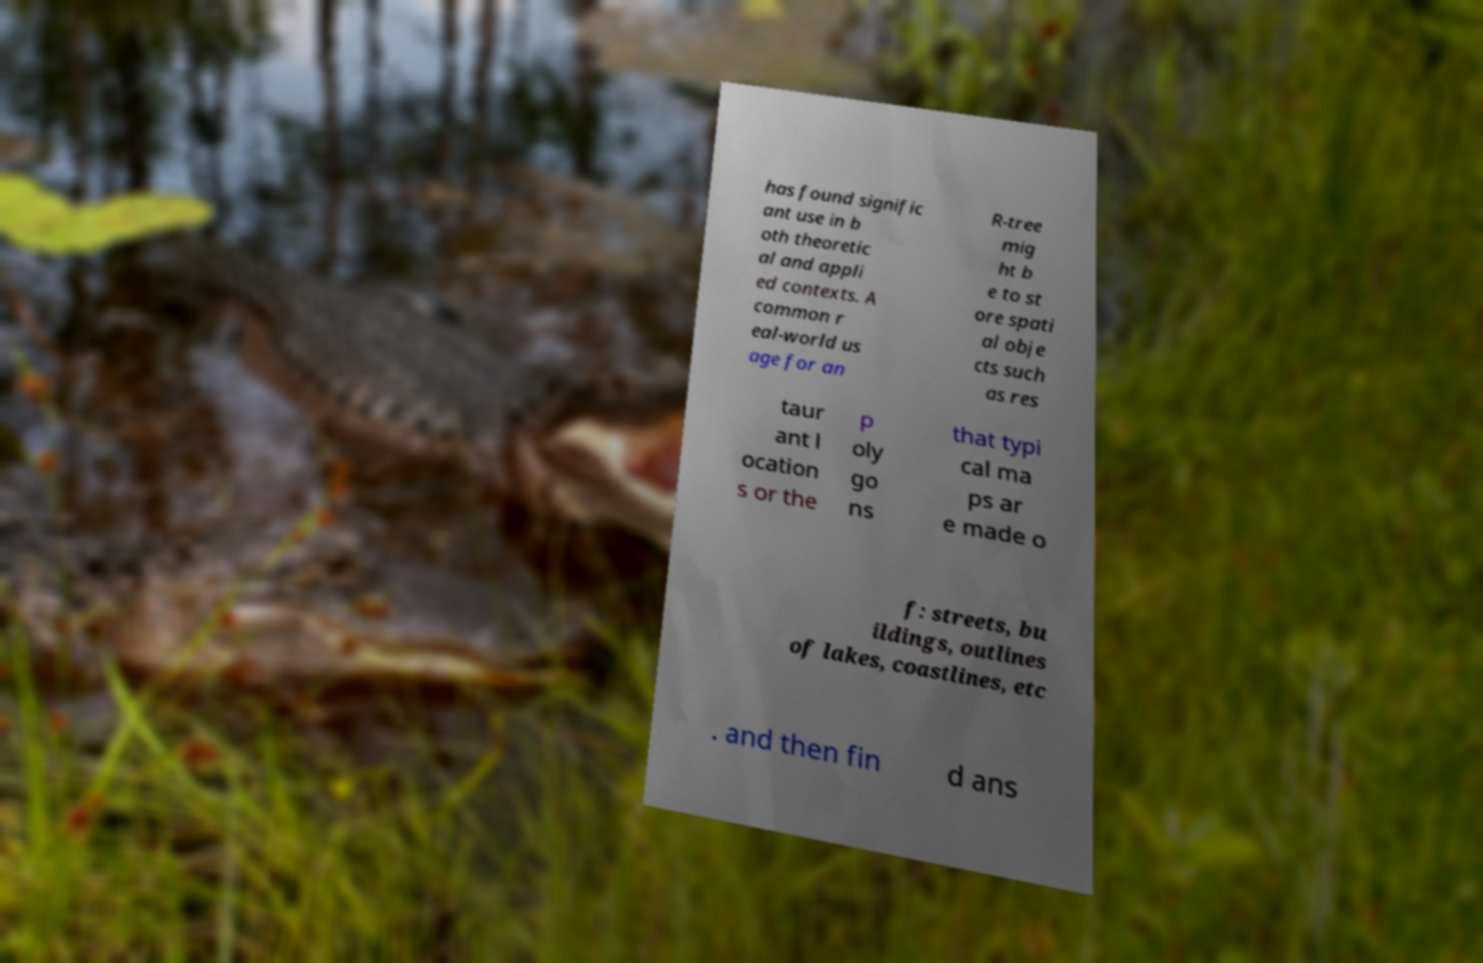Can you read and provide the text displayed in the image?This photo seems to have some interesting text. Can you extract and type it out for me? has found signific ant use in b oth theoretic al and appli ed contexts. A common r eal-world us age for an R-tree mig ht b e to st ore spati al obje cts such as res taur ant l ocation s or the p oly go ns that typi cal ma ps ar e made o f: streets, bu ildings, outlines of lakes, coastlines, etc . and then fin d ans 